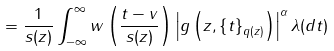Convert formula to latex. <formula><loc_0><loc_0><loc_500><loc_500>= \frac { 1 } { s ( z ) } \int _ { - \infty } ^ { \infty } w \left ( \frac { t - v } { s ( z ) } \right ) \left | g \left ( z , \left \{ t \right \} _ { q ( z ) } \right ) \right | ^ { \alpha } \lambda ( d t )</formula> 